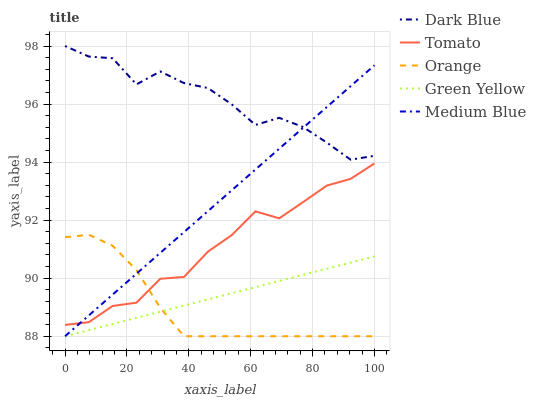Does Orange have the minimum area under the curve?
Answer yes or no. Yes. Does Dark Blue have the maximum area under the curve?
Answer yes or no. Yes. Does Dark Blue have the minimum area under the curve?
Answer yes or no. No. Does Orange have the maximum area under the curve?
Answer yes or no. No. Is Medium Blue the smoothest?
Answer yes or no. Yes. Is Dark Blue the roughest?
Answer yes or no. Yes. Is Orange the smoothest?
Answer yes or no. No. Is Orange the roughest?
Answer yes or no. No. Does Orange have the lowest value?
Answer yes or no. Yes. Does Dark Blue have the lowest value?
Answer yes or no. No. Does Dark Blue have the highest value?
Answer yes or no. Yes. Does Orange have the highest value?
Answer yes or no. No. Is Green Yellow less than Dark Blue?
Answer yes or no. Yes. Is Dark Blue greater than Tomato?
Answer yes or no. Yes. Does Tomato intersect Orange?
Answer yes or no. Yes. Is Tomato less than Orange?
Answer yes or no. No. Is Tomato greater than Orange?
Answer yes or no. No. Does Green Yellow intersect Dark Blue?
Answer yes or no. No. 